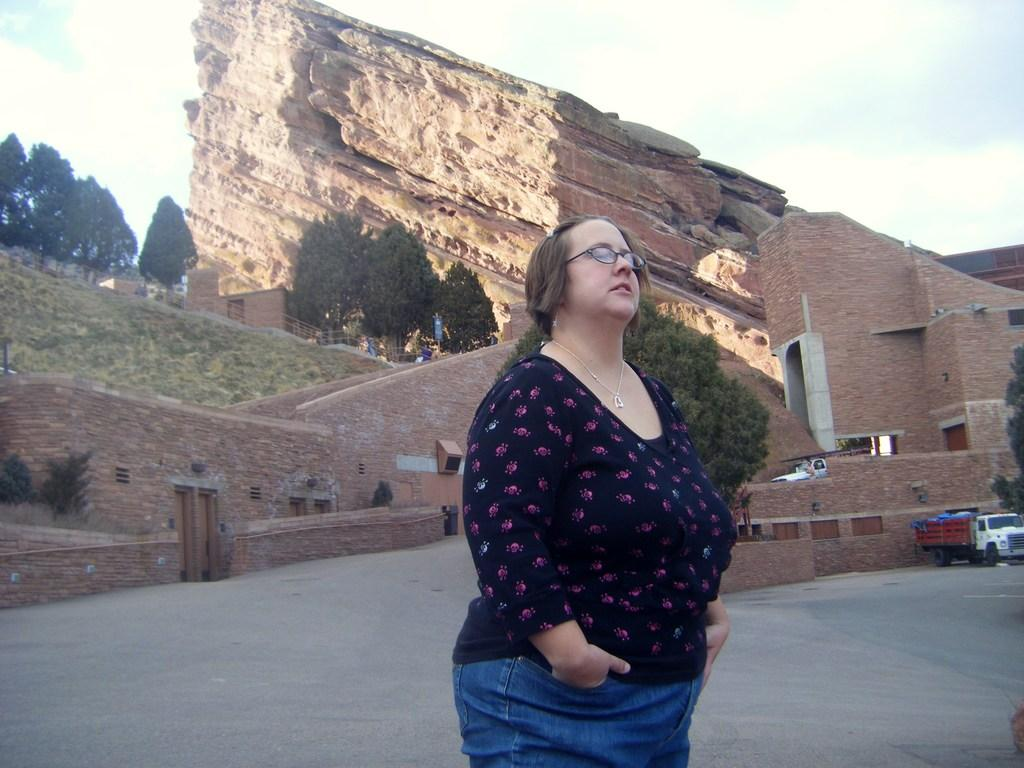What is the woman doing in the image? The woman is standing on the road in the image. What else can be seen in the image besides the woman? There is a vehicle, a fort, trees, and the sky with clouds visible in the background. What type of orange is the woman holding in the image? There is no orange present in the image; the woman is standing on the road without holding any fruit. 